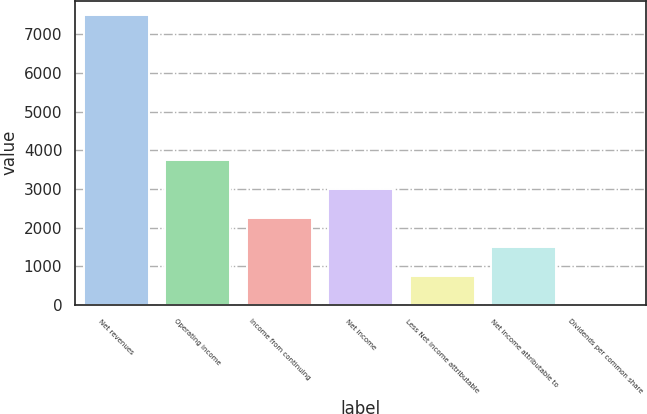Convert chart. <chart><loc_0><loc_0><loc_500><loc_500><bar_chart><fcel>Net revenues<fcel>Operating income<fcel>Income from continuing<fcel>Net income<fcel>Less Net income attributable<fcel>Net income attributable to<fcel>Dividends per common share<nl><fcel>7493<fcel>3747.27<fcel>2248.97<fcel>2998.12<fcel>750.67<fcel>1499.82<fcel>1.52<nl></chart> 